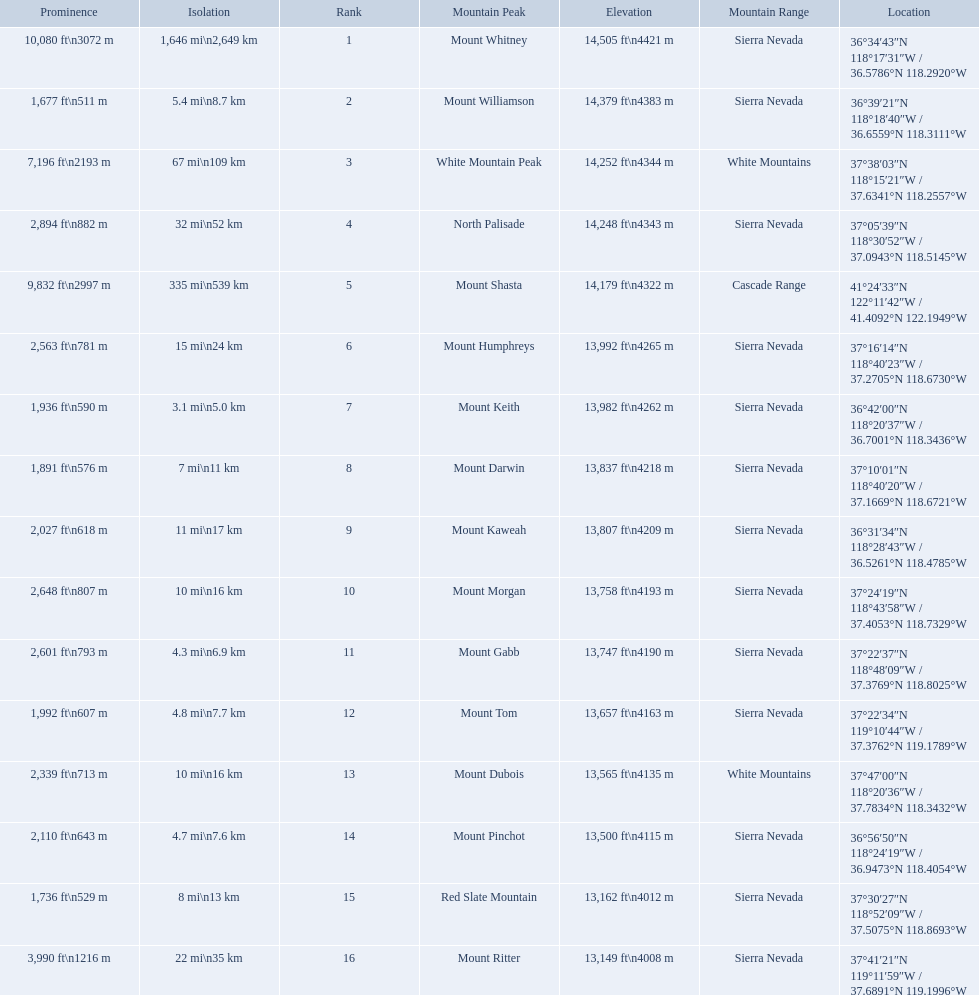What are all of the peaks? Mount Whitney, Mount Williamson, White Mountain Peak, North Palisade, Mount Shasta, Mount Humphreys, Mount Keith, Mount Darwin, Mount Kaweah, Mount Morgan, Mount Gabb, Mount Tom, Mount Dubois, Mount Pinchot, Red Slate Mountain, Mount Ritter. Where are they located? Sierra Nevada, Sierra Nevada, White Mountains, Sierra Nevada, Cascade Range, Sierra Nevada, Sierra Nevada, Sierra Nevada, Sierra Nevada, Sierra Nevada, Sierra Nevada, Sierra Nevada, White Mountains, Sierra Nevada, Sierra Nevada, Sierra Nevada. How tall are they? 14,505 ft\n4421 m, 14,379 ft\n4383 m, 14,252 ft\n4344 m, 14,248 ft\n4343 m, 14,179 ft\n4322 m, 13,992 ft\n4265 m, 13,982 ft\n4262 m, 13,837 ft\n4218 m, 13,807 ft\n4209 m, 13,758 ft\n4193 m, 13,747 ft\n4190 m, 13,657 ft\n4163 m, 13,565 ft\n4135 m, 13,500 ft\n4115 m, 13,162 ft\n4012 m, 13,149 ft\n4008 m. What about just the peaks in the sierra nevadas? 14,505 ft\n4421 m, 14,379 ft\n4383 m, 14,248 ft\n4343 m, 13,992 ft\n4265 m, 13,982 ft\n4262 m, 13,837 ft\n4218 m, 13,807 ft\n4209 m, 13,758 ft\n4193 m, 13,747 ft\n4190 m, 13,657 ft\n4163 m, 13,500 ft\n4115 m, 13,162 ft\n4012 m, 13,149 ft\n4008 m. And of those, which is the tallest? Mount Whitney. 